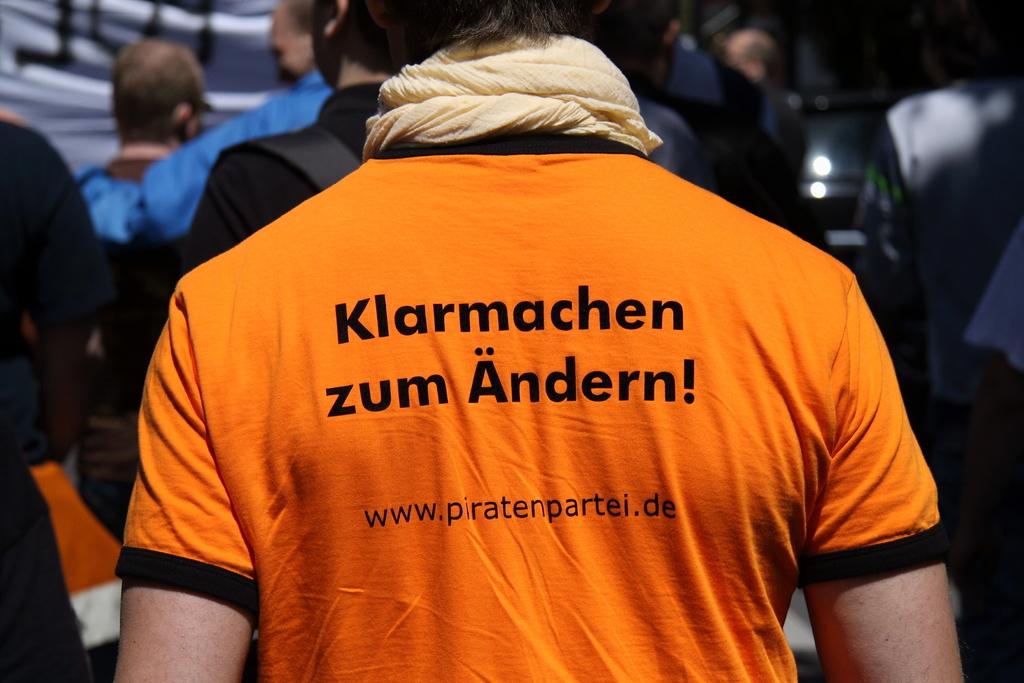What is the website that is advertised?
Keep it short and to the point. Www.piratenpartei.de. What does the shirt say?
Your response must be concise. Klarmachen zum andern. 